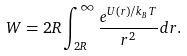Convert formula to latex. <formula><loc_0><loc_0><loc_500><loc_500>W = 2 R \int _ { 2 R } ^ { \infty } { \frac { e ^ { U ( r ) / k _ { B } T } } { r ^ { 2 } } d r } .</formula> 